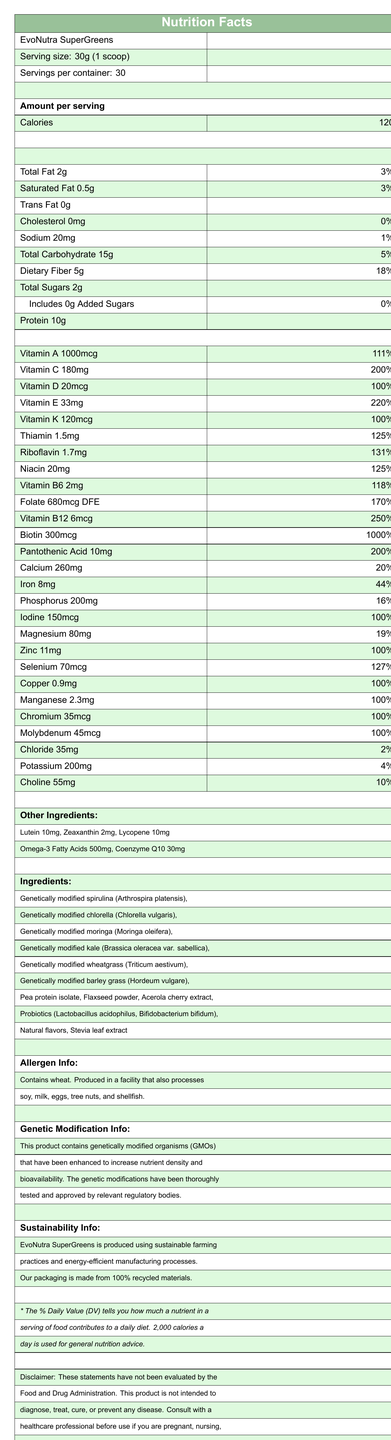what is the serving size of EvoNutra SuperGreens? The serving size is explicitly mentioned as "30g (1 scoop)" in the document.
Answer: 30g (1 scoop) how many servings are there per container? The document specifies there are 30 servings per container.
Answer: 30 how many calories are there per serving? It is written that each serving contains 120 calories.
Answer: 120 what is the main ingredient in EvoNutra SuperGreens? The first ingredient listed is genetically modified spirulina, indicating it's the main ingredient.
Answer: Genetically modified spirulina (Arthrospira platensis) how much protein is in each serving? Each serving contains 10g of protein, as detailed in the document.
Answer: 10g which vitamin has the highest daily value percentage? Biotin has a daily value percentage of 1000%, the highest listed in the document.
Answer: Biotin how much total fat is in one serving? The document states there is 2g of total fat per serving.
Answer: 2g is there any cholesterol in EvoNutra SuperGreens? (Yes/No) It is noted that the cholesterol amount is 0mg, indicating there isn't any cholesterol.
Answer: No which of the following is a genetically modified ingredient in EvoNutra SuperGreens? A. Genetically modified spirulina B. Natural flavors C. Flaxseed powder D. Stevia leaf extract Multiple ingredients are genetically modified, but Genetically modified spirulina (A) is highlighted among the options.
Answer: A what is the amount of Vitamin C per serving? A. 1000mcg B. 180mg C. 20mcg D. 33mg The document specifies that the amount of Vitamin C per serving is 180mg.
Answer: B which type of facility processes EvoNutra SuperGreens? A. A facility that only processes wheat. B. A facility that processes various allergens such as soy, milk, eggs, tree nuts, and shellfish. C. A facility that only processes vegetables. The allergen information section states that the product is produced in a facility that also processes soy, milk, eggs, tree nuts, and shellfish.
Answer: B describe the main idea of the Nutrition Facts Label for EvoNutra SuperGreens The detailed explanation discusses the serving size, calorific value, nutrient content, ingredients list, allergen warnings, genetic modification details, and sustainability information, along with the disclaimer regarding FDA evaluation.
Answer: The Nutrition Facts Label provides comprehensive information on the nutrient content per serving of EvoNutra SuperGreens, a genetically modified superfood, including details about its high levels of various vitamins, minerals, and other beneficial compounds. It also includes information on the ingredients, allergen warnings, genetic modifications, and sustainability practices. Additionally, there is a disclaimer about the product not being evaluated by the FDA for treating any diseases. what is the daily value percentage for dietary fiber? The daily value percentage for dietary fiber is indicated as 18%.
Answer: 18% does EvoNutra SuperGreens contain any added sugars? The document specifies that there are 0g of added sugars, which means there are no added sugars.
Answer: No is there information about the environmental impact of EvoNutra SuperGreens? The document includes a sustainability section stating that EvoNutra SuperGreens is produced with sustainable farming practices, energy-efficient manufacturing processes, and 100% recycled packaging materials.
Answer: Yes does the label mention if the genetic modifications have been tested and approved by regulatory bodies? (True/False) The section on genetic modification info clearly states that the modifications have been thoroughly tested and approved by relevant regulatory bodies.
Answer: True can you determine the exact proportion of genetically modified spirulina (Arthrospira platensis) in the total ingredients? The document lists genetically modified spirulina among the ingredients, but does not provide any specific proportion or percentage.
Answer: Not enough information 